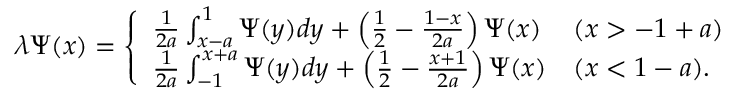Convert formula to latex. <formula><loc_0><loc_0><loc_500><loc_500>\begin{array} { r } { \lambda \Psi ( x ) = \left \{ \begin{array} { l l } { \frac { 1 } { 2 a } \int _ { x - a } ^ { 1 } \Psi ( y ) d y + \left ( \frac { 1 } { 2 } - \frac { 1 - x } { 2 a } \right ) \Psi ( x ) } & { ( x > - 1 + a ) } \\ { \frac { 1 } { 2 a } \int _ { - 1 } ^ { x + a } \Psi ( y ) d y + \left ( \frac { 1 } { 2 } - \frac { x + 1 } { 2 a } \right ) \Psi ( x ) } & { ( x < 1 - a ) . } \end{array} } \end{array}</formula> 